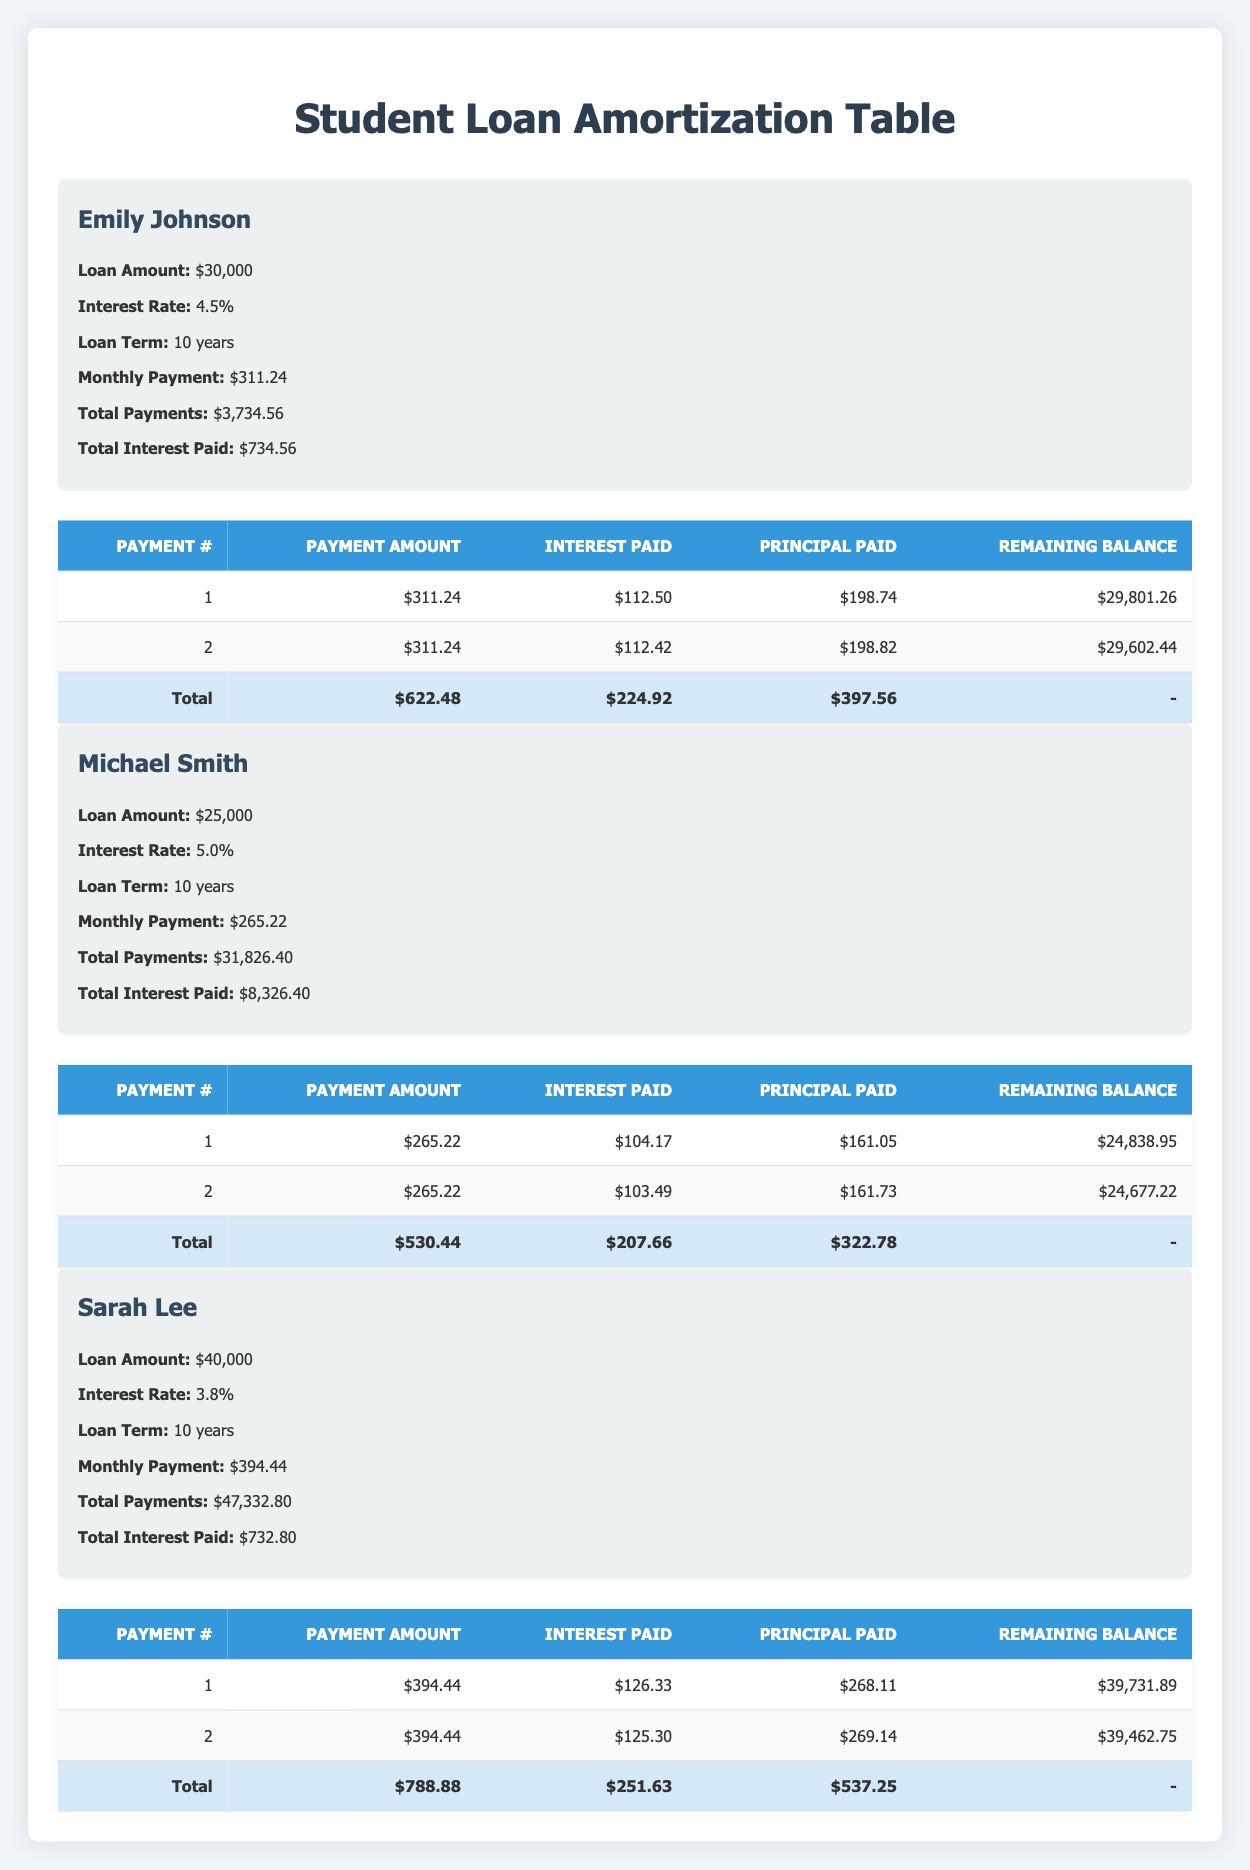What is the monthly payment for Michael Smith? The table lists Michael Smith's monthly payment as $265.22.
Answer: $265.22 What is the total interest paid by Sarah Lee? The total interest paid by Sarah Lee is displayed in the table as $732.80.
Answer: $732.80 How much interest did Emily Johnson pay in her first payment? In Emily Johnson's first payment, the interest paid is $112.50 as noted in her payment schedule.
Answer: $112.50 What is the remaining balance after the second payment for Michael Smith? After Michael Smith's second payment, the remaining balance is $24,677.22, which is shown in the payment schedule.
Answer: $24,677.22 What is the total amount paid by Emily Johnson after her first two payments? Emily Johnson's first two payments total $622.48, which is the sum of her payment amounts: $311.24 + $311.24 = $622.48.
Answer: $622.48 Did Sarah Lee pay less total interest than Emily Johnson? Yes, Emily Johnson paid a total of $734.56 in interest, which is more than Sarah Lee's total interest of $732.80, so Sarah Lee paid less.
Answer: Yes How much more total interest did Michael Smith pay compared to Sarah Lee? Michael Smith paid $8,326.40 in total interest, while Sarah Lee paid $732.80. The difference is $8,326.40 - $732.80 = $7,593.60.
Answer: $7,593.60 What was the principal paid in Michael Smith’s first payment? In Michael Smith's first payment, the principal paid is $161.05, which can be found in his payment schedule.
Answer: $161.05 What is the average monthly payment for all three borrowers? To find the average monthly payment, sum the monthly payments of all borrowers: $311.24 + $265.22 + $394.44 = $970.90, then divide by 3 (the number of borrowers): $970.90 / 3 = $323.63.
Answer: $323.63 After the first payment, what was the remaining balance for Sarah Lee? Sarah Lee's remaining balance after her first payment was $39,731.89 as indicated in her payment schedule.
Answer: $39,731.89 